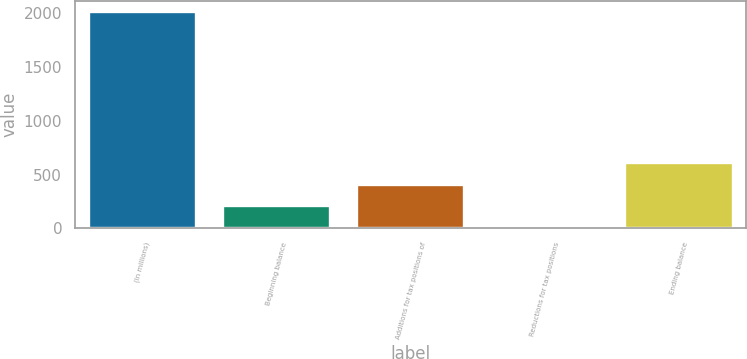<chart> <loc_0><loc_0><loc_500><loc_500><bar_chart><fcel>(In millions)<fcel>Beginning balance<fcel>Additions for tax positions of<fcel>Reductions for tax positions<fcel>Ending balance<nl><fcel>2017<fcel>204.4<fcel>405.8<fcel>3<fcel>607.2<nl></chart> 